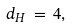<formula> <loc_0><loc_0><loc_500><loc_500>d _ { H } \, = \, 4 ,</formula> 